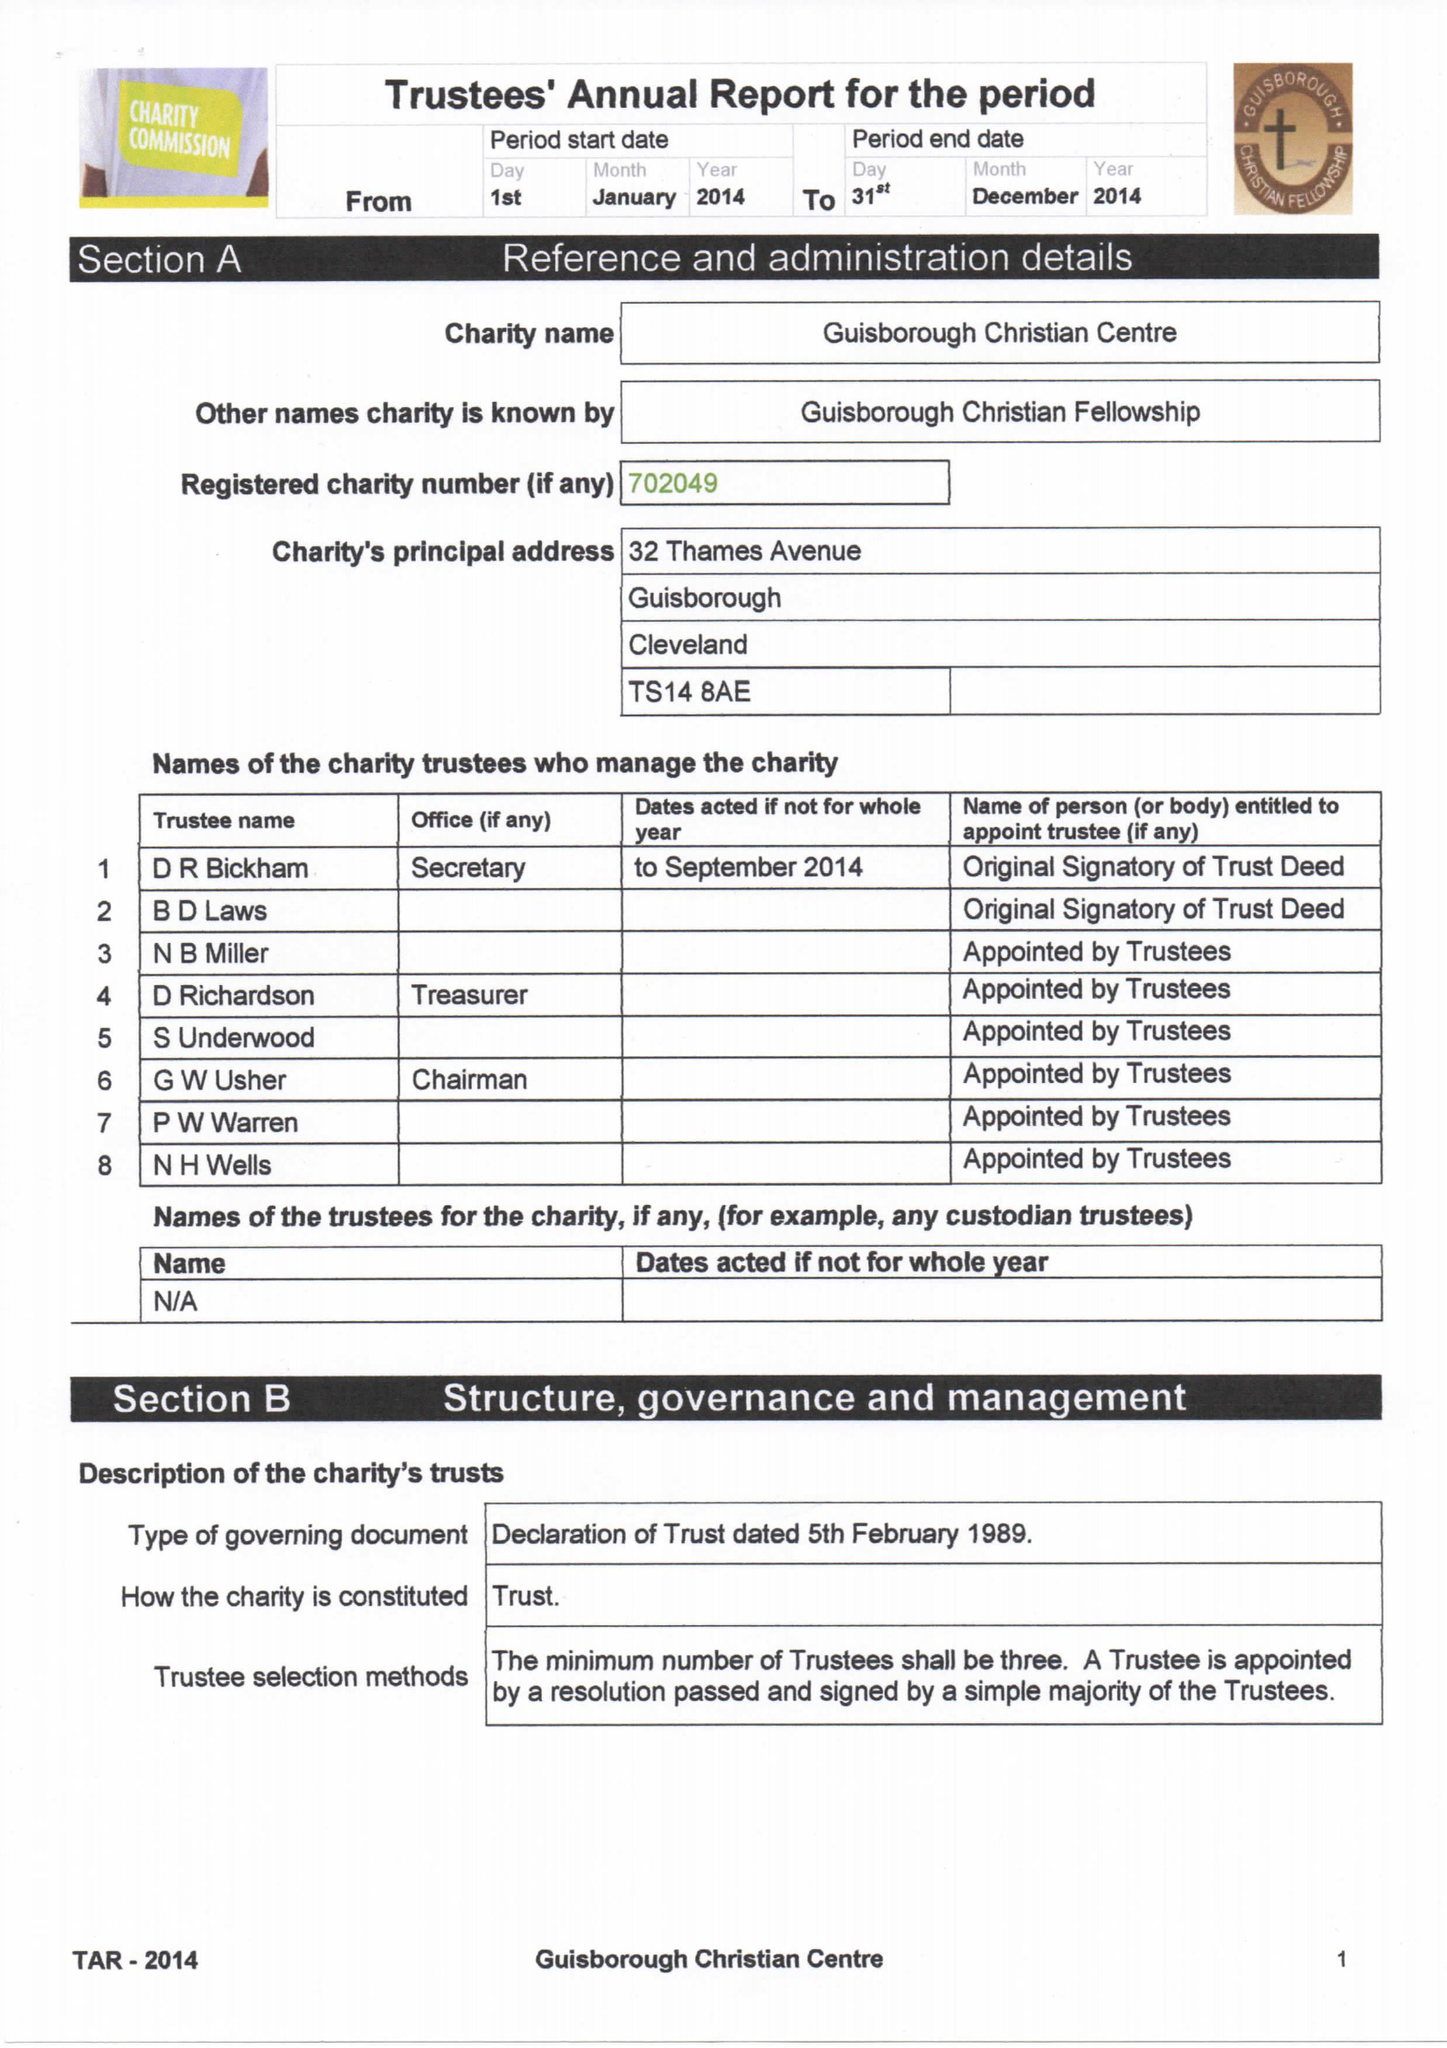What is the value for the address__postcode?
Answer the question using a single word or phrase. TS12 2NE 